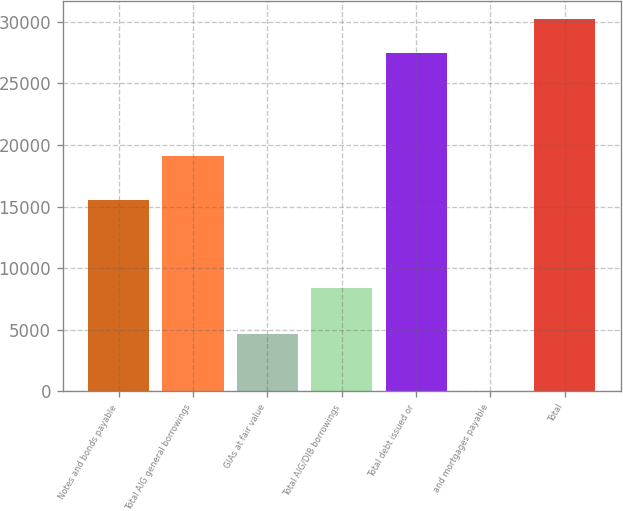Convert chart. <chart><loc_0><loc_0><loc_500><loc_500><bar_chart><fcel>Notes and bonds payable<fcel>Total AIG general borrowings<fcel>GIAs at fair value<fcel>Total AIG/DIB borrowings<fcel>Total debt issued or<fcel>and mortgages payable<fcel>Total<nl><fcel>15570<fcel>19106<fcel>4648<fcel>8370<fcel>27476<fcel>58<fcel>30223.6<nl></chart> 